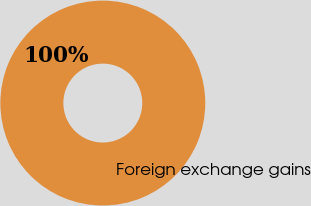Convert chart to OTSL. <chart><loc_0><loc_0><loc_500><loc_500><pie_chart><fcel>Foreign exchange gains<nl><fcel>100.0%<nl></chart> 